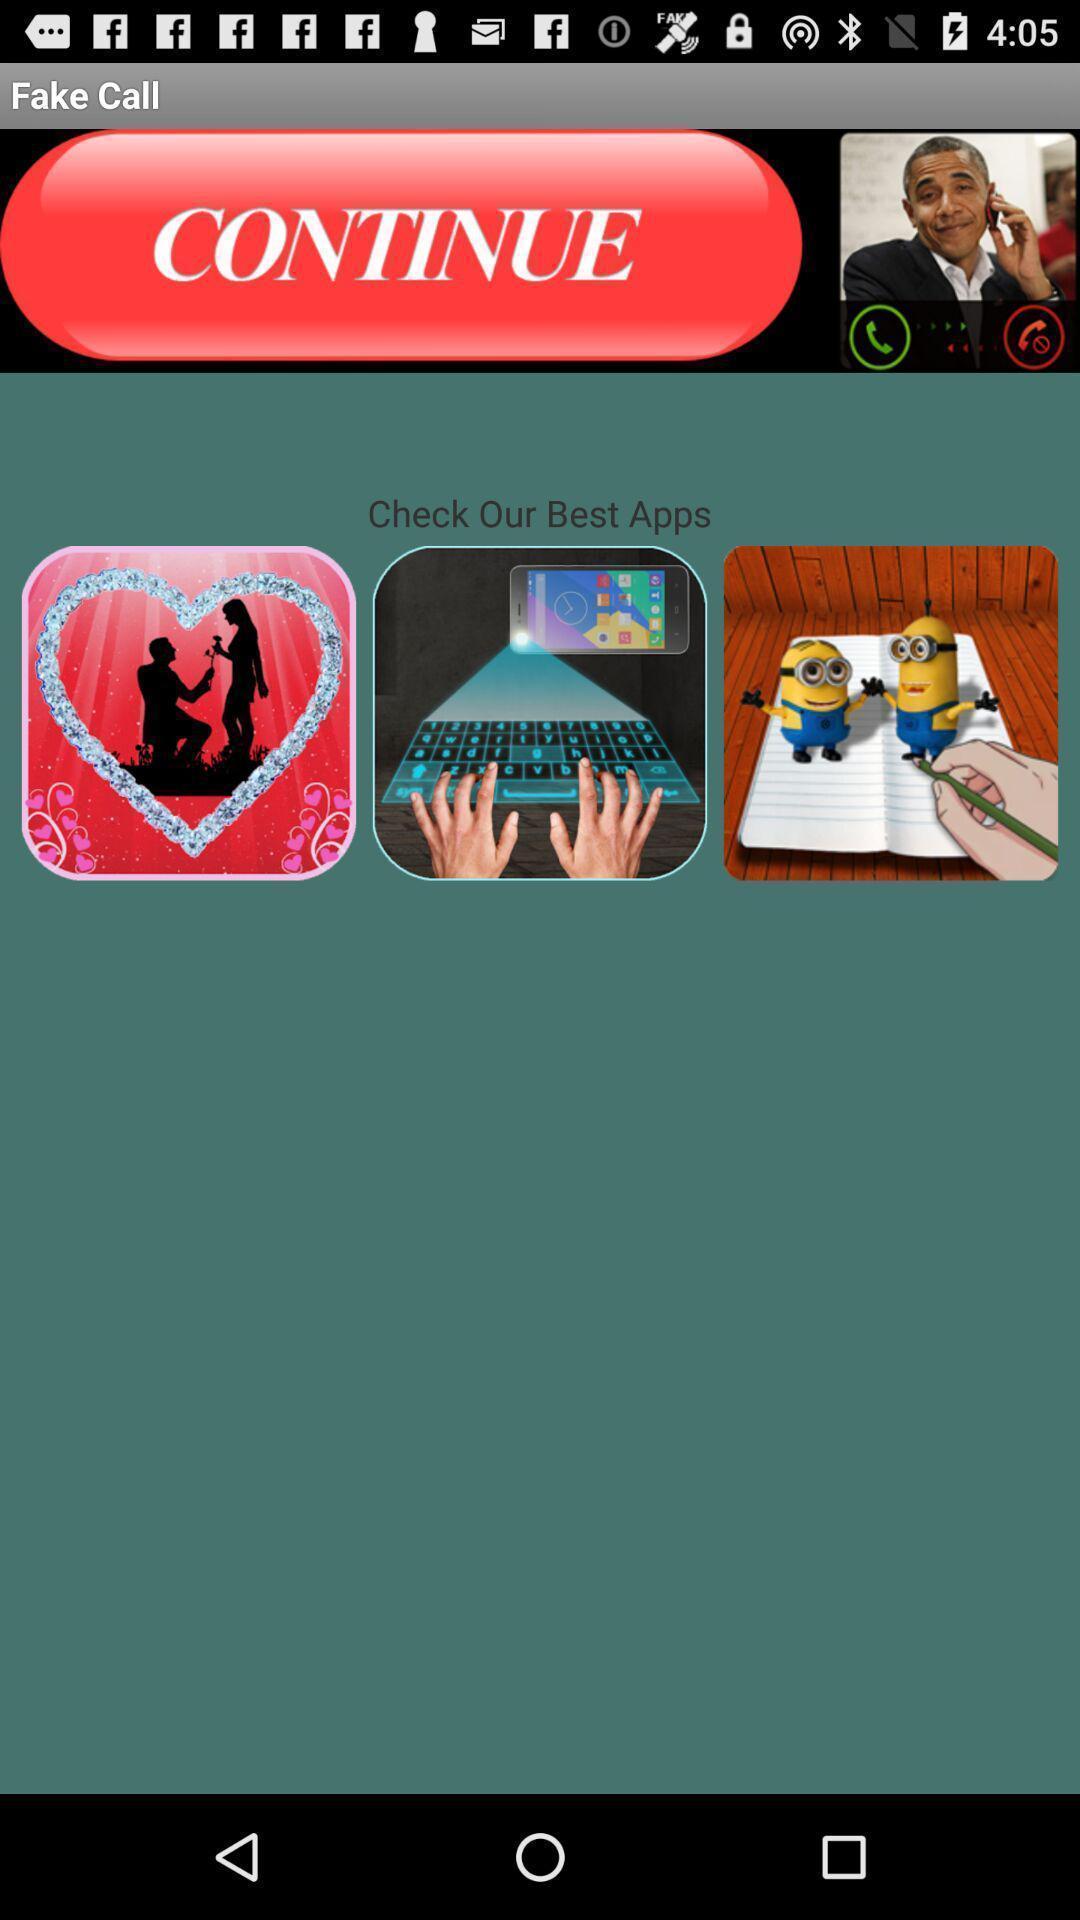Summarize the information in this screenshot. Screen showing check our best apps. 